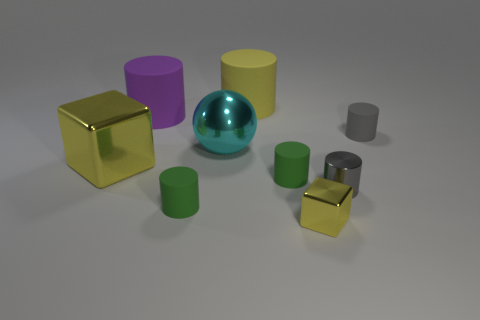Do the large purple object and the small yellow thing have the same material?
Provide a short and direct response. No. Are there any yellow things left of the big cyan object?
Keep it short and to the point. Yes. What material is the small green object that is right of the big cyan metal sphere in front of the purple cylinder?
Ensure brevity in your answer.  Rubber. What is the size of the gray rubber object that is the same shape as the purple matte thing?
Provide a succinct answer. Small. Does the tiny shiny cube have the same color as the big metallic cube?
Give a very brief answer. Yes. What color is the metallic thing that is both behind the small metallic cylinder and right of the large yellow shiny block?
Keep it short and to the point. Cyan. Does the yellow metal cube left of the yellow cylinder have the same size as the gray matte cylinder?
Offer a terse response. No. Is there any other thing that has the same shape as the large cyan shiny thing?
Ensure brevity in your answer.  No. Does the cyan object have the same material as the big cylinder right of the large sphere?
Make the answer very short. No. What number of green objects are either rubber things or big shiny balls?
Give a very brief answer. 2. 